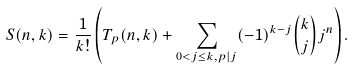Convert formula to latex. <formula><loc_0><loc_0><loc_500><loc_500>S ( n , k ) = \frac { 1 } { k ! } \left ( T _ { p } ( n , k ) + \sum _ { 0 < j \leq k , p | j } ( - 1 ) ^ { k - j } { k \choose j } j ^ { n } \right ) .</formula> 